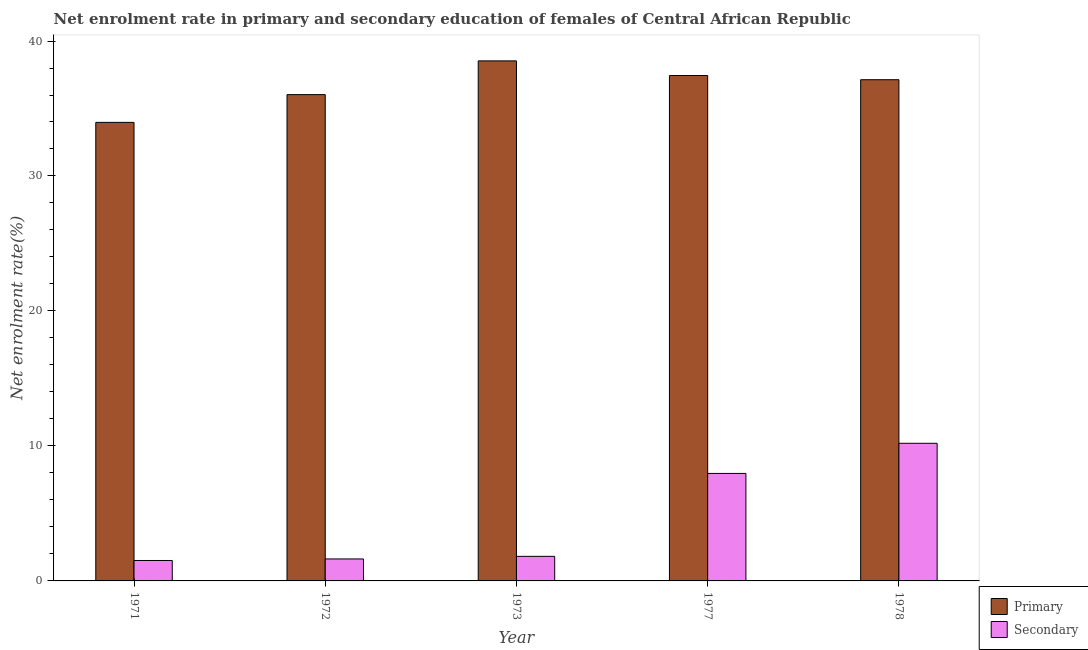Are the number of bars on each tick of the X-axis equal?
Give a very brief answer. Yes. What is the label of the 3rd group of bars from the left?
Your answer should be compact. 1973. In how many cases, is the number of bars for a given year not equal to the number of legend labels?
Your answer should be very brief. 0. What is the enrollment rate in primary education in 1971?
Give a very brief answer. 33.97. Across all years, what is the maximum enrollment rate in primary education?
Provide a short and direct response. 38.53. Across all years, what is the minimum enrollment rate in primary education?
Keep it short and to the point. 33.97. In which year was the enrollment rate in secondary education maximum?
Offer a terse response. 1978. What is the total enrollment rate in primary education in the graph?
Your answer should be very brief. 183.11. What is the difference between the enrollment rate in secondary education in 1977 and that in 1978?
Give a very brief answer. -2.23. What is the difference between the enrollment rate in primary education in 1972 and the enrollment rate in secondary education in 1977?
Your answer should be compact. -1.42. What is the average enrollment rate in primary education per year?
Provide a succinct answer. 36.62. In the year 1973, what is the difference between the enrollment rate in secondary education and enrollment rate in primary education?
Provide a short and direct response. 0. What is the ratio of the enrollment rate in primary education in 1973 to that in 1978?
Your response must be concise. 1.04. Is the difference between the enrollment rate in primary education in 1971 and 1973 greater than the difference between the enrollment rate in secondary education in 1971 and 1973?
Make the answer very short. No. What is the difference between the highest and the second highest enrollment rate in secondary education?
Provide a succinct answer. 2.23. What is the difference between the highest and the lowest enrollment rate in primary education?
Offer a very short reply. 4.56. In how many years, is the enrollment rate in primary education greater than the average enrollment rate in primary education taken over all years?
Make the answer very short. 3. Is the sum of the enrollment rate in secondary education in 1972 and 1978 greater than the maximum enrollment rate in primary education across all years?
Offer a terse response. Yes. What does the 1st bar from the left in 1972 represents?
Offer a terse response. Primary. What does the 2nd bar from the right in 1978 represents?
Your response must be concise. Primary. Are all the bars in the graph horizontal?
Your response must be concise. No. How many years are there in the graph?
Your answer should be very brief. 5. Where does the legend appear in the graph?
Offer a terse response. Bottom right. How many legend labels are there?
Offer a terse response. 2. What is the title of the graph?
Ensure brevity in your answer.  Net enrolment rate in primary and secondary education of females of Central African Republic. Does "Private credit bureau" appear as one of the legend labels in the graph?
Offer a very short reply. No. What is the label or title of the Y-axis?
Provide a short and direct response. Net enrolment rate(%). What is the Net enrolment rate(%) of Primary in 1971?
Keep it short and to the point. 33.97. What is the Net enrolment rate(%) of Secondary in 1971?
Make the answer very short. 1.51. What is the Net enrolment rate(%) in Primary in 1972?
Make the answer very short. 36.03. What is the Net enrolment rate(%) of Secondary in 1972?
Provide a succinct answer. 1.63. What is the Net enrolment rate(%) in Primary in 1973?
Provide a succinct answer. 38.53. What is the Net enrolment rate(%) in Secondary in 1973?
Your answer should be compact. 1.82. What is the Net enrolment rate(%) in Primary in 1977?
Your response must be concise. 37.44. What is the Net enrolment rate(%) in Secondary in 1977?
Provide a short and direct response. 7.96. What is the Net enrolment rate(%) in Primary in 1978?
Your answer should be compact. 37.13. What is the Net enrolment rate(%) in Secondary in 1978?
Offer a very short reply. 10.2. Across all years, what is the maximum Net enrolment rate(%) in Primary?
Offer a terse response. 38.53. Across all years, what is the maximum Net enrolment rate(%) of Secondary?
Provide a succinct answer. 10.2. Across all years, what is the minimum Net enrolment rate(%) of Primary?
Give a very brief answer. 33.97. Across all years, what is the minimum Net enrolment rate(%) in Secondary?
Give a very brief answer. 1.51. What is the total Net enrolment rate(%) of Primary in the graph?
Your answer should be very brief. 183.11. What is the total Net enrolment rate(%) in Secondary in the graph?
Offer a very short reply. 23.12. What is the difference between the Net enrolment rate(%) of Primary in 1971 and that in 1972?
Offer a terse response. -2.06. What is the difference between the Net enrolment rate(%) in Secondary in 1971 and that in 1972?
Give a very brief answer. -0.11. What is the difference between the Net enrolment rate(%) of Primary in 1971 and that in 1973?
Provide a short and direct response. -4.56. What is the difference between the Net enrolment rate(%) in Secondary in 1971 and that in 1973?
Give a very brief answer. -0.31. What is the difference between the Net enrolment rate(%) in Primary in 1971 and that in 1977?
Keep it short and to the point. -3.47. What is the difference between the Net enrolment rate(%) in Secondary in 1971 and that in 1977?
Make the answer very short. -6.45. What is the difference between the Net enrolment rate(%) in Primary in 1971 and that in 1978?
Provide a succinct answer. -3.16. What is the difference between the Net enrolment rate(%) in Secondary in 1971 and that in 1978?
Your answer should be very brief. -8.68. What is the difference between the Net enrolment rate(%) in Primary in 1972 and that in 1973?
Make the answer very short. -2.5. What is the difference between the Net enrolment rate(%) of Secondary in 1972 and that in 1973?
Your response must be concise. -0.19. What is the difference between the Net enrolment rate(%) in Primary in 1972 and that in 1977?
Keep it short and to the point. -1.42. What is the difference between the Net enrolment rate(%) of Secondary in 1972 and that in 1977?
Your response must be concise. -6.34. What is the difference between the Net enrolment rate(%) in Primary in 1972 and that in 1978?
Offer a terse response. -1.1. What is the difference between the Net enrolment rate(%) in Secondary in 1972 and that in 1978?
Keep it short and to the point. -8.57. What is the difference between the Net enrolment rate(%) in Primary in 1973 and that in 1977?
Ensure brevity in your answer.  1.08. What is the difference between the Net enrolment rate(%) of Secondary in 1973 and that in 1977?
Offer a terse response. -6.14. What is the difference between the Net enrolment rate(%) in Primary in 1973 and that in 1978?
Your answer should be compact. 1.4. What is the difference between the Net enrolment rate(%) of Secondary in 1973 and that in 1978?
Offer a terse response. -8.38. What is the difference between the Net enrolment rate(%) in Primary in 1977 and that in 1978?
Make the answer very short. 0.31. What is the difference between the Net enrolment rate(%) in Secondary in 1977 and that in 1978?
Offer a terse response. -2.23. What is the difference between the Net enrolment rate(%) of Primary in 1971 and the Net enrolment rate(%) of Secondary in 1972?
Make the answer very short. 32.34. What is the difference between the Net enrolment rate(%) in Primary in 1971 and the Net enrolment rate(%) in Secondary in 1973?
Your response must be concise. 32.15. What is the difference between the Net enrolment rate(%) in Primary in 1971 and the Net enrolment rate(%) in Secondary in 1977?
Provide a succinct answer. 26.01. What is the difference between the Net enrolment rate(%) in Primary in 1971 and the Net enrolment rate(%) in Secondary in 1978?
Give a very brief answer. 23.77. What is the difference between the Net enrolment rate(%) of Primary in 1972 and the Net enrolment rate(%) of Secondary in 1973?
Give a very brief answer. 34.21. What is the difference between the Net enrolment rate(%) in Primary in 1972 and the Net enrolment rate(%) in Secondary in 1977?
Keep it short and to the point. 28.06. What is the difference between the Net enrolment rate(%) in Primary in 1972 and the Net enrolment rate(%) in Secondary in 1978?
Make the answer very short. 25.83. What is the difference between the Net enrolment rate(%) in Primary in 1973 and the Net enrolment rate(%) in Secondary in 1977?
Offer a terse response. 30.56. What is the difference between the Net enrolment rate(%) in Primary in 1973 and the Net enrolment rate(%) in Secondary in 1978?
Your answer should be compact. 28.33. What is the difference between the Net enrolment rate(%) in Primary in 1977 and the Net enrolment rate(%) in Secondary in 1978?
Give a very brief answer. 27.25. What is the average Net enrolment rate(%) in Primary per year?
Keep it short and to the point. 36.62. What is the average Net enrolment rate(%) of Secondary per year?
Give a very brief answer. 4.62. In the year 1971, what is the difference between the Net enrolment rate(%) in Primary and Net enrolment rate(%) in Secondary?
Offer a very short reply. 32.46. In the year 1972, what is the difference between the Net enrolment rate(%) in Primary and Net enrolment rate(%) in Secondary?
Ensure brevity in your answer.  34.4. In the year 1973, what is the difference between the Net enrolment rate(%) of Primary and Net enrolment rate(%) of Secondary?
Give a very brief answer. 36.71. In the year 1977, what is the difference between the Net enrolment rate(%) of Primary and Net enrolment rate(%) of Secondary?
Offer a terse response. 29.48. In the year 1978, what is the difference between the Net enrolment rate(%) in Primary and Net enrolment rate(%) in Secondary?
Keep it short and to the point. 26.94. What is the ratio of the Net enrolment rate(%) in Primary in 1971 to that in 1972?
Your answer should be compact. 0.94. What is the ratio of the Net enrolment rate(%) in Secondary in 1971 to that in 1972?
Provide a succinct answer. 0.93. What is the ratio of the Net enrolment rate(%) in Primary in 1971 to that in 1973?
Provide a succinct answer. 0.88. What is the ratio of the Net enrolment rate(%) of Secondary in 1971 to that in 1973?
Your response must be concise. 0.83. What is the ratio of the Net enrolment rate(%) in Primary in 1971 to that in 1977?
Provide a succinct answer. 0.91. What is the ratio of the Net enrolment rate(%) of Secondary in 1971 to that in 1977?
Ensure brevity in your answer.  0.19. What is the ratio of the Net enrolment rate(%) of Primary in 1971 to that in 1978?
Offer a very short reply. 0.91. What is the ratio of the Net enrolment rate(%) of Secondary in 1971 to that in 1978?
Your response must be concise. 0.15. What is the ratio of the Net enrolment rate(%) of Primary in 1972 to that in 1973?
Provide a succinct answer. 0.94. What is the ratio of the Net enrolment rate(%) of Secondary in 1972 to that in 1973?
Provide a succinct answer. 0.89. What is the ratio of the Net enrolment rate(%) of Primary in 1972 to that in 1977?
Make the answer very short. 0.96. What is the ratio of the Net enrolment rate(%) in Secondary in 1972 to that in 1977?
Your response must be concise. 0.2. What is the ratio of the Net enrolment rate(%) in Primary in 1972 to that in 1978?
Offer a very short reply. 0.97. What is the ratio of the Net enrolment rate(%) of Secondary in 1972 to that in 1978?
Ensure brevity in your answer.  0.16. What is the ratio of the Net enrolment rate(%) of Primary in 1973 to that in 1977?
Make the answer very short. 1.03. What is the ratio of the Net enrolment rate(%) in Secondary in 1973 to that in 1977?
Your answer should be very brief. 0.23. What is the ratio of the Net enrolment rate(%) in Primary in 1973 to that in 1978?
Your answer should be very brief. 1.04. What is the ratio of the Net enrolment rate(%) of Secondary in 1973 to that in 1978?
Keep it short and to the point. 0.18. What is the ratio of the Net enrolment rate(%) of Primary in 1977 to that in 1978?
Your response must be concise. 1.01. What is the ratio of the Net enrolment rate(%) of Secondary in 1977 to that in 1978?
Make the answer very short. 0.78. What is the difference between the highest and the second highest Net enrolment rate(%) of Primary?
Provide a succinct answer. 1.08. What is the difference between the highest and the second highest Net enrolment rate(%) in Secondary?
Keep it short and to the point. 2.23. What is the difference between the highest and the lowest Net enrolment rate(%) of Primary?
Your response must be concise. 4.56. What is the difference between the highest and the lowest Net enrolment rate(%) of Secondary?
Your answer should be compact. 8.68. 